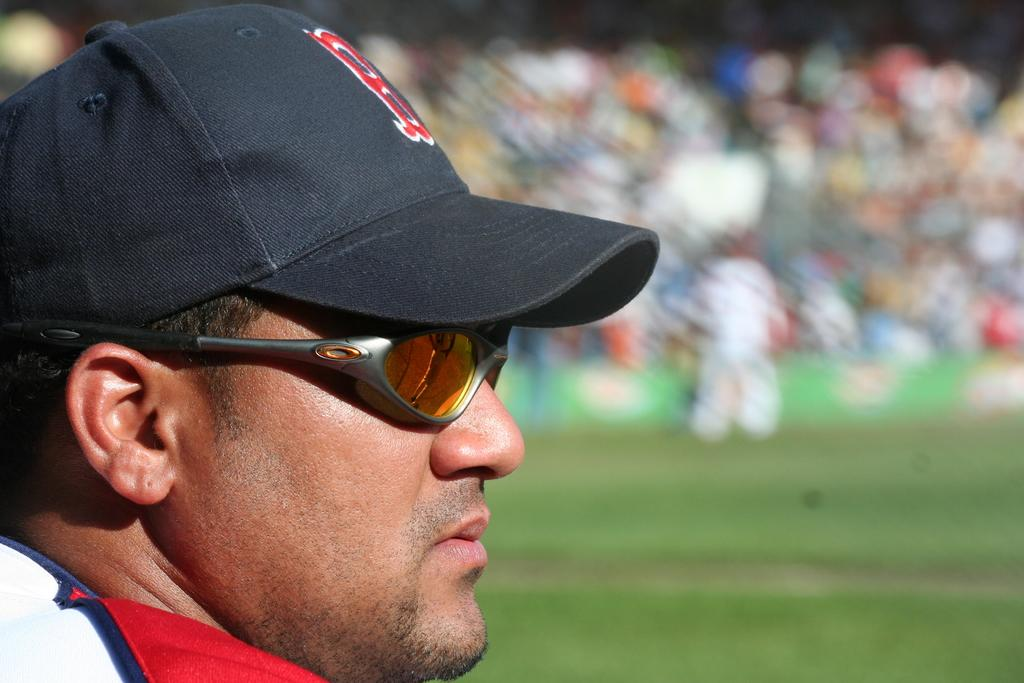Who is present in the image? There is a man in the image. What is the man wearing on his head? The man is wearing a cap. What is the man wearing to protect his eyes? The man is wearing goggles. What type of shirt is the man wearing? The man is wearing a t-shirt. What can be seen in the background of the image? There is a stadium in the background of the image. What is the audience doing in the stadium? The audience is visible in the stadium, but their actions are not specified. What type of surface is at the bottom of the image? There is grass at the bottom of the image. How many legs does the attraction have in the image? There is no attraction present in the image, so it is not possible to determine the number of legs it might have. 